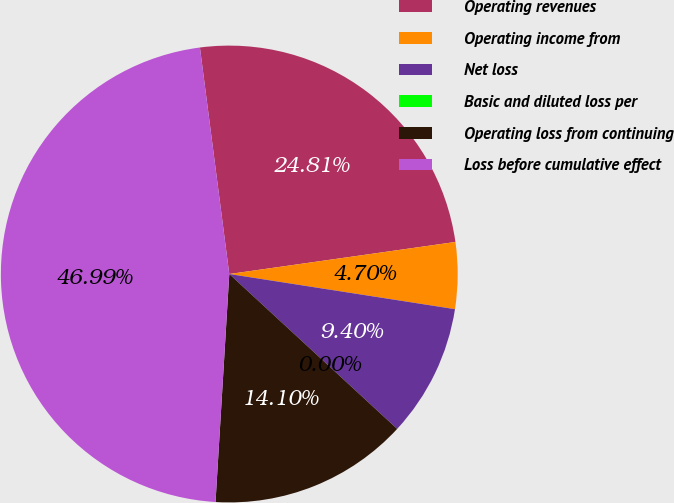Convert chart to OTSL. <chart><loc_0><loc_0><loc_500><loc_500><pie_chart><fcel>Operating revenues<fcel>Operating income from<fcel>Net loss<fcel>Basic and diluted loss per<fcel>Operating loss from continuing<fcel>Loss before cumulative effect<nl><fcel>24.81%<fcel>4.7%<fcel>9.4%<fcel>0.0%<fcel>14.1%<fcel>46.99%<nl></chart> 